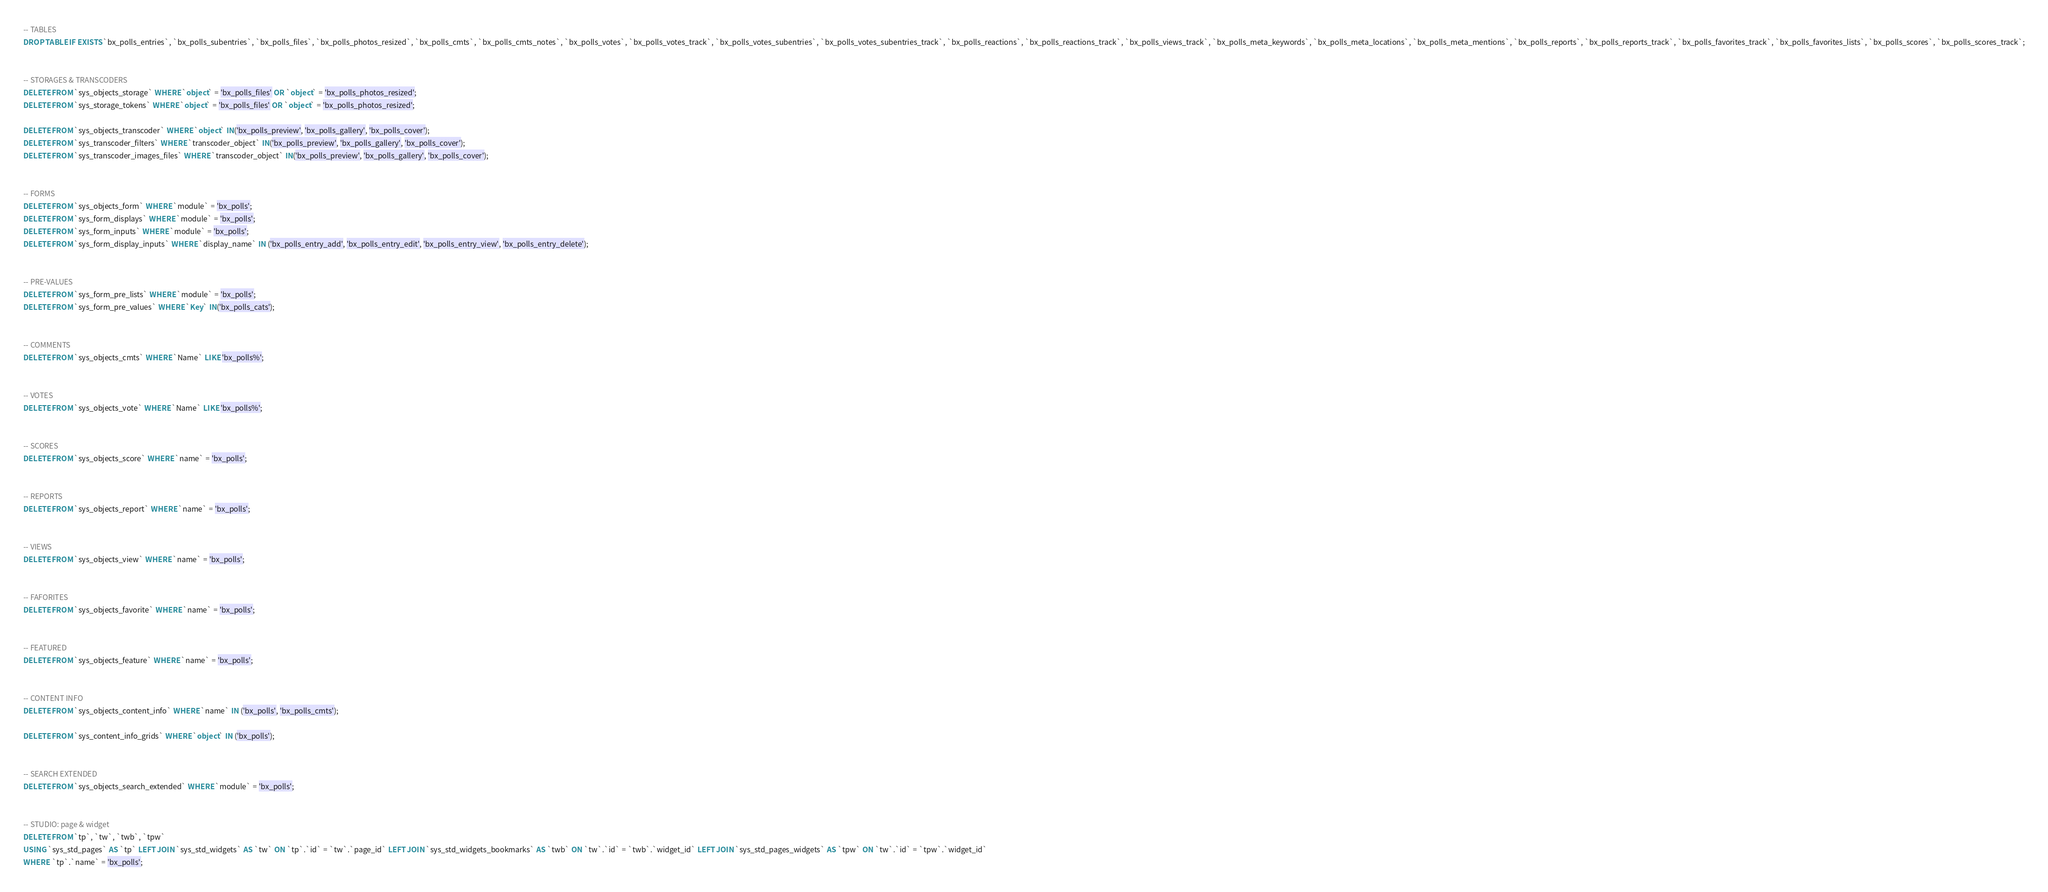Convert code to text. <code><loc_0><loc_0><loc_500><loc_500><_SQL_>
-- TABLES
DROP TABLE IF EXISTS `bx_polls_entries`, `bx_polls_subentries`, `bx_polls_files`, `bx_polls_photos_resized`, `bx_polls_cmts`, `bx_polls_cmts_notes`, `bx_polls_votes`, `bx_polls_votes_track`, `bx_polls_votes_subentries`, `bx_polls_votes_subentries_track`, `bx_polls_reactions`, `bx_polls_reactions_track`, `bx_polls_views_track`, `bx_polls_meta_keywords`, `bx_polls_meta_locations`, `bx_polls_meta_mentions`, `bx_polls_reports`, `bx_polls_reports_track`, `bx_polls_favorites_track`, `bx_polls_favorites_lists`, `bx_polls_scores`, `bx_polls_scores_track`;


-- STORAGES & TRANSCODERS
DELETE FROM `sys_objects_storage` WHERE `object` = 'bx_polls_files' OR `object` = 'bx_polls_photos_resized';
DELETE FROM `sys_storage_tokens` WHERE `object` = 'bx_polls_files' OR `object` = 'bx_polls_photos_resized';

DELETE FROM `sys_objects_transcoder` WHERE `object` IN('bx_polls_preview', 'bx_polls_gallery', 'bx_polls_cover');
DELETE FROM `sys_transcoder_filters` WHERE `transcoder_object` IN('bx_polls_preview', 'bx_polls_gallery', 'bx_polls_cover');
DELETE FROM `sys_transcoder_images_files` WHERE `transcoder_object` IN('bx_polls_preview', 'bx_polls_gallery', 'bx_polls_cover');


-- FORMS
DELETE FROM `sys_objects_form` WHERE `module` = 'bx_polls';
DELETE FROM `sys_form_displays` WHERE `module` = 'bx_polls';
DELETE FROM `sys_form_inputs` WHERE `module` = 'bx_polls';
DELETE FROM `sys_form_display_inputs` WHERE `display_name` IN ('bx_polls_entry_add', 'bx_polls_entry_edit', 'bx_polls_entry_view', 'bx_polls_entry_delete');


-- PRE-VALUES
DELETE FROM `sys_form_pre_lists` WHERE `module` = 'bx_polls';
DELETE FROM `sys_form_pre_values` WHERE `Key` IN('bx_polls_cats');


-- COMMENTS
DELETE FROM `sys_objects_cmts` WHERE `Name` LIKE 'bx_polls%';


-- VOTES
DELETE FROM `sys_objects_vote` WHERE `Name` LIKE 'bx_polls%';


-- SCORES
DELETE FROM `sys_objects_score` WHERE `name` = 'bx_polls';


-- REPORTS
DELETE FROM `sys_objects_report` WHERE `name` = 'bx_polls';


-- VIEWS
DELETE FROM `sys_objects_view` WHERE `name` = 'bx_polls';


-- FAFORITES
DELETE FROM `sys_objects_favorite` WHERE `name` = 'bx_polls';


-- FEATURED
DELETE FROM `sys_objects_feature` WHERE `name` = 'bx_polls';


-- CONTENT INFO
DELETE FROM `sys_objects_content_info` WHERE `name` IN ('bx_polls', 'bx_polls_cmts');

DELETE FROM `sys_content_info_grids` WHERE `object` IN ('bx_polls');


-- SEARCH EXTENDED
DELETE FROM `sys_objects_search_extended` WHERE `module` = 'bx_polls';


-- STUDIO: page & widget
DELETE FROM `tp`, `tw`, `twb`, `tpw` 
USING `sys_std_pages` AS `tp` LEFT JOIN `sys_std_widgets` AS `tw` ON `tp`.`id` = `tw`.`page_id` LEFT JOIN `sys_std_widgets_bookmarks` AS `twb` ON `tw`.`id` = `twb`.`widget_id` LEFT JOIN `sys_std_pages_widgets` AS `tpw` ON `tw`.`id` = `tpw`.`widget_id`
WHERE  `tp`.`name` = 'bx_polls';
</code> 